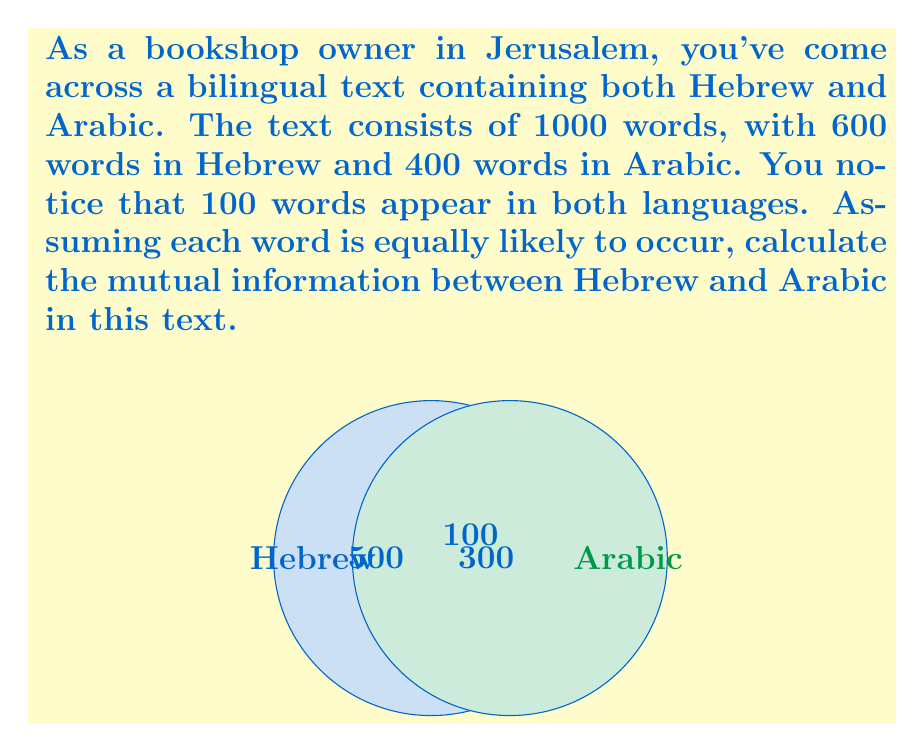Solve this math problem. Let's approach this step-by-step:

1) First, we need to calculate the probabilities:
   P(Hebrew) = 600/1000 = 0.6
   P(Arabic) = 400/1000 = 0.4
   P(Hebrew and Arabic) = 100/1000 = 0.1

2) The mutual information I(X;Y) is defined as:
   $$I(X;Y) = \sum_{x \in X} \sum_{y \in Y} p(x,y) \log_2 \frac{p(x,y)}{p(x)p(y)}$$

3) In our case, we have:
   $$I(\text{Hebrew};\text{Arabic}) = p(\text{H},\text{A}) \log_2 \frac{p(\text{H},\text{A})}{p(\text{H})p(\text{A})} + p(\text{H},\text{not A}) \log_2 \frac{p(\text{H},\text{not A})}{p(\text{H})p(\text{not A})} + p(\text{not H},\text{A}) \log_2 \frac{p(\text{not H},\text{A})}{p(\text{not H})p(\text{A})} + p(\text{not H},\text{not A}) \log_2 \frac{p(\text{not H},\text{not A})}{p(\text{not H})p(\text{not A})}$$

4) Let's calculate each term:
   p(H,A) = 0.1
   p(H,not A) = 0.5
   p(not H,A) = 0.3
   p(not H,not A) = 0.1

5) Plugging these into the equation:
   $$I(\text{Hebrew};\text{Arabic}) = 0.1 \log_2 \frac{0.1}{0.6 \times 0.4} + 0.5 \log_2 \frac{0.5}{0.6 \times 0.6} + 0.3 \log_2 \frac{0.3}{0.4 \times 0.4} + 0.1 \log_2 \frac{0.1}{0.4 \times 0.6}$$

6) Calculating each term:
   $$I(\text{Hebrew};\text{Arabic}) = 0.1 \log_2 (0.4167) + 0.5 \log_2 (1.3889) + 0.3 \log_2 (1.875) + 0.1 \log_2 (0.4167)$$
   $$= 0.1 \times (-1.2630) + 0.5 \times 0.4737 + 0.3 \times 0.9069 + 0.1 \times (-1.2630)$$
   $$= -0.1263 + 0.2369 + 0.2721 - 0.1263$$

7) Adding these up:
   $$I(\text{Hebrew};\text{Arabic}) = 0.2564$$ bits
Answer: 0.2564 bits 